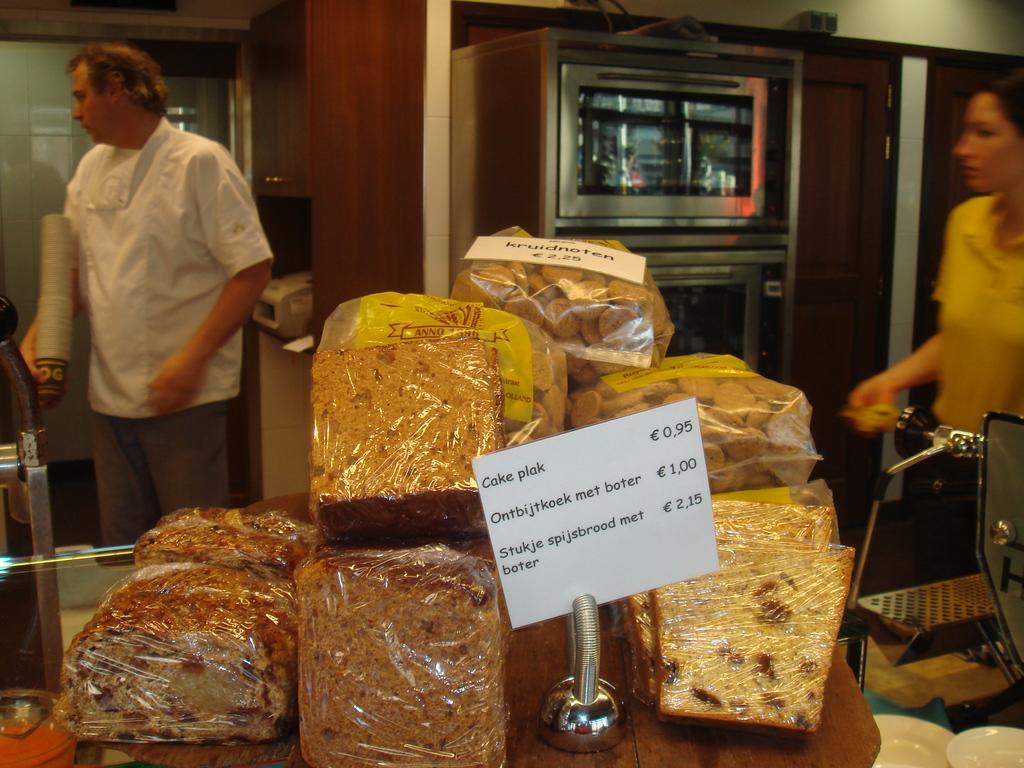Please provide a concise description of this image. In this image I can see few food items on the table and I can also see the white color board. In the background I can see two persons standing and I can also see an oven. 